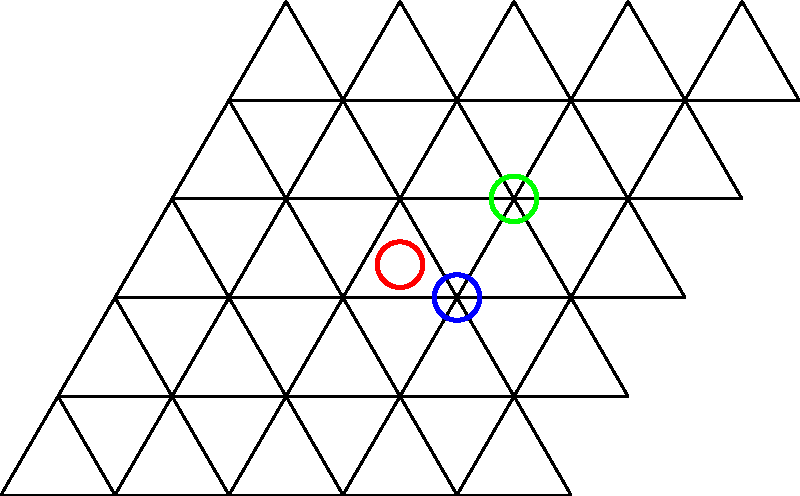In the tessellation of equilateral triangles shown above, three vertices are highlighted in red, blue, and green. If we consider each highlighted vertex as a "beat" in a rhythmic pattern, what is the time signature that best represents the repeating pattern formed by these three beats, assuming the shortest distance between any two beats represents one unit of time? To determine the time signature, we need to follow these steps:

1. Identify the pattern: The highlighted vertices form a repeating triangular pattern.

2. Determine the unit of time: The shortest distance between any two beats (vertices) is considered one unit of time. This is the distance between the red and blue vertices.

3. Calculate the distances:
   - From red to blue: 1 unit
   - From blue to green: $\sqrt{3}$ units
   - From green back to red: 1 unit

4. Convert to musical timing:
   - 1 unit can be considered as one beat
   - $\sqrt{3}$ units is approximately 1.73 beats, which we can round to 2 beats for musical purposes

5. Sum up the total beats in the pattern:
   1 + 2 + 1 = 4 beats total

6. Determine the division of beats:
   The pattern naturally divides into three parts (red to blue, blue to green, green to red), suggesting a triple meter.

7. Conclude the time signature:
   The pattern has 4 beats total, divided into 3 parts. This corresponds to a 12/8 time signature in musical notation, where each beat is subdivided into triplets.
Answer: 12/8 